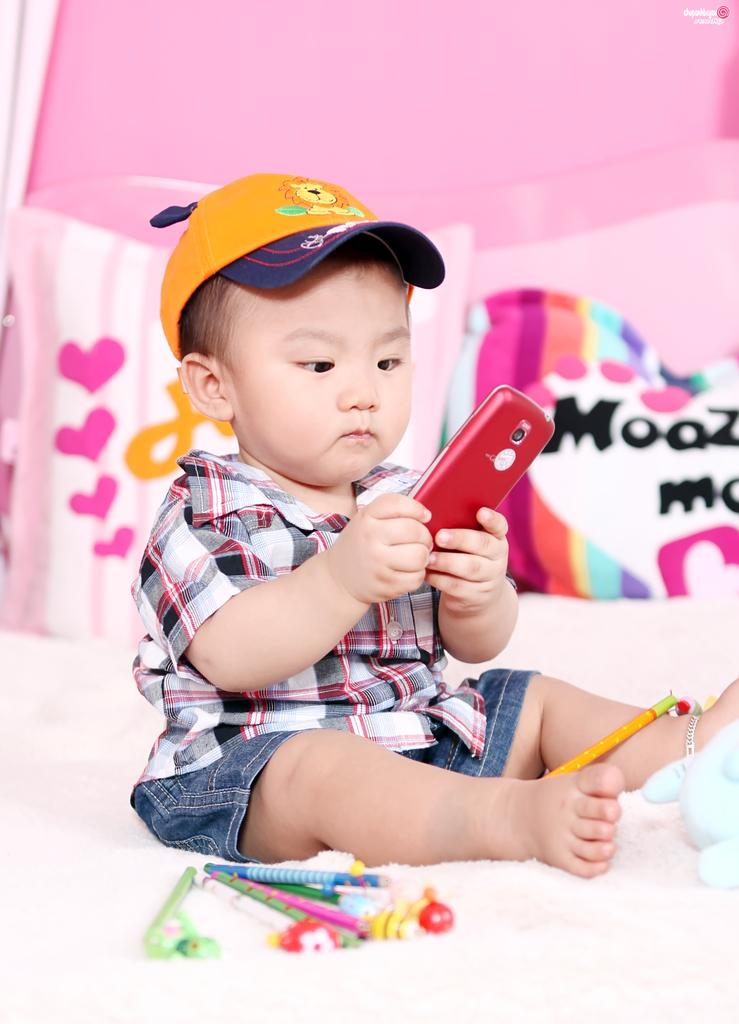What is the main subject of the image? The main subject of the image is a kid. What is the kid doing in the image? The kid is sitting in the image. What is the kid holding in the image? The kid is holding a mobile in the image. What is the kid wearing in the image? The kid is wearing a cap in the image. What other objects can be seen in the image? There are pencils and a toy in the image. Where is the toy located in the image? The toy is on a bed in the image. What is behind the kid in the image? There are pillows behind the kid in the image. What type of straw is the pig eating in the image? There is no straw or pig present in the image. 